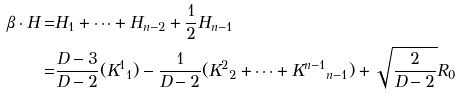Convert formula to latex. <formula><loc_0><loc_0><loc_500><loc_500>\beta \cdot H = & H _ { 1 } + \dots + H _ { n - 2 } + \frac { 1 } { 2 } H _ { n - 1 } \\ = & \frac { D - 3 } { D - 2 } ( { K ^ { 1 } } _ { 1 } ) - \frac { 1 } { D - 2 } ( { K ^ { 2 } } _ { 2 } + \dots + { K ^ { n - 1 } } _ { n - 1 } ) + \sqrt { \frac { 2 } { D - 2 } } R _ { 0 }</formula> 